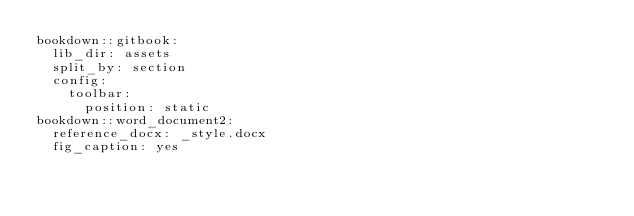<code> <loc_0><loc_0><loc_500><loc_500><_YAML_>bookdown::gitbook:
  lib_dir: assets
  split_by: section
  config:
    toolbar:
      position: static
bookdown::word_document2: 
  reference_docx: _style.docx
  fig_caption: yes
</code> 